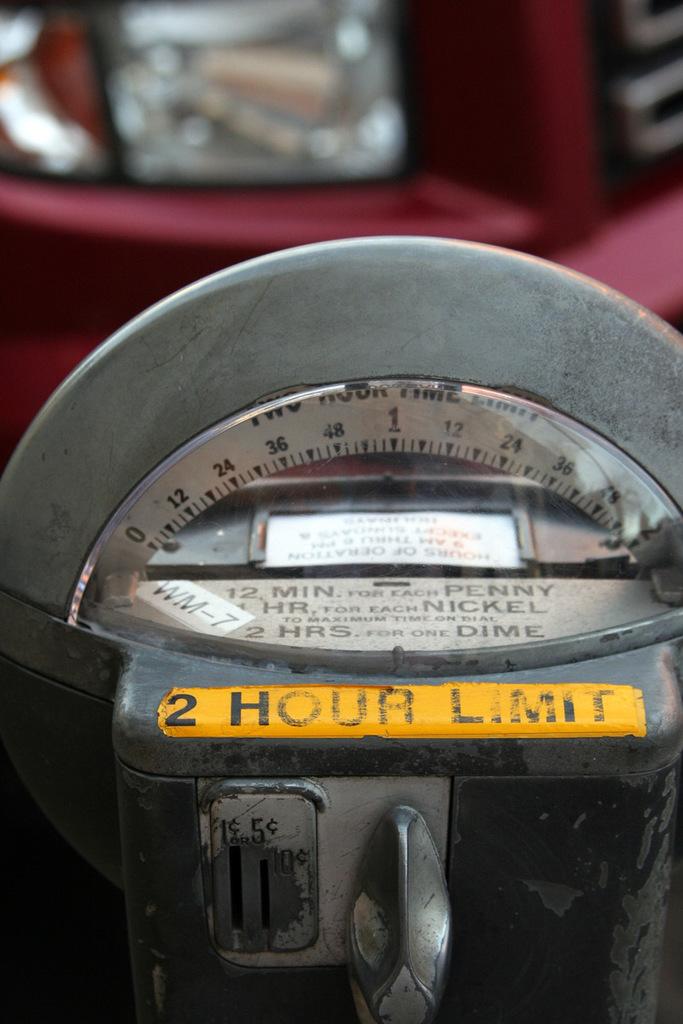How long can we park at this meter?
Make the answer very short. 2 hours. How much does it cost to park for 2 hours?
Give a very brief answer. One dime. 